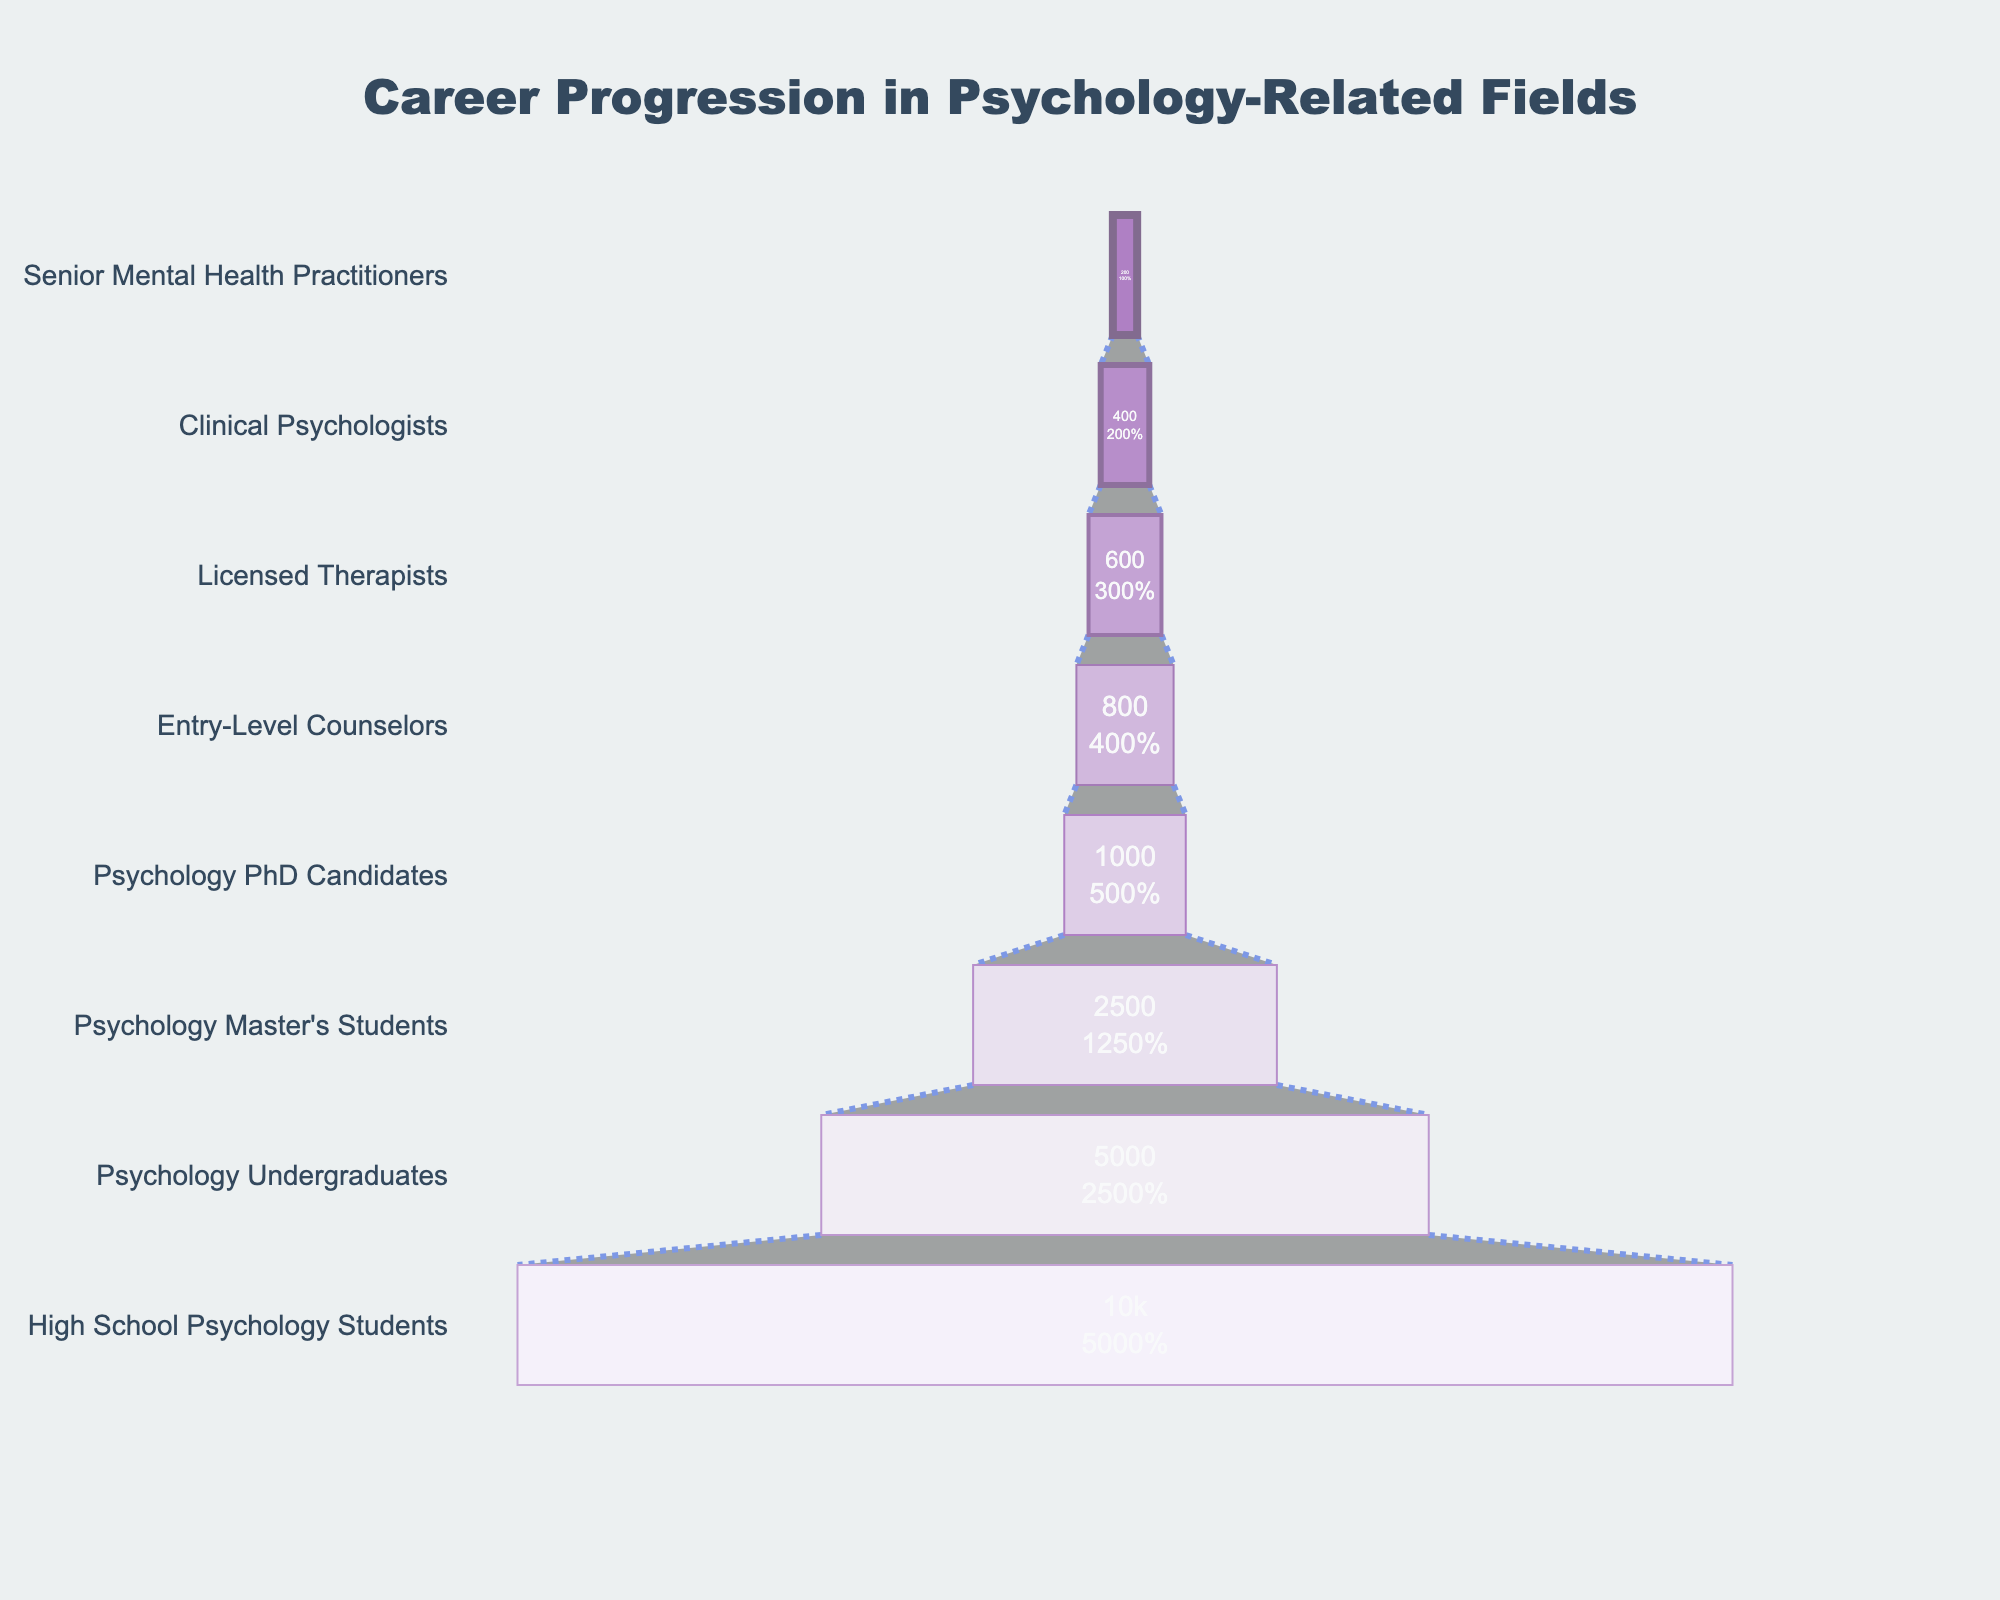What is the title of the figure? The title is usually placed at the top center of the figure and visually distinct in terms of font size and color. Here, it reads "Career Progression in Psychology-Related Fields".
Answer: Career Progression in Psychology-Related Fields Which stage has the highest number of people? The widest part of the funnel represents the stage with the highest number of people, which is at the top. Here, the "High School Psychology Students" stage is the widest with 10,000 people.
Answer: High School Psychology Students What is the number of people at the "Clinical Psychologists" stage? Locate the label "Clinical Psychologists" on the y-axis, then look at the corresponding value inside the funnel section. It shows there are 400 people at this stage.
Answer: 400 How many stages are represented in the funnel chart? Count the number of distinct sections in the funnel. There are eight stages listed from "High School Psychology Students" to "Senior Mental Health Practitioners".
Answer: 8 Which stage has the lowest retention of people? The narrowest part of the funnel indicates the stage with the smallest number of people, which is "Senior Mental Health Practitioners" with 200 people.
Answer: Senior Mental Health Practitioners What percentage of the initial number of people becomes "Licensed Therapists"? To find the percentage, divide the number of "Licensed Therapists" by the number of "High School Psychology Students" and multiply by 100: (600 / 10,000) * 100 = 6%.
Answer: 6% How many more "Entry-Level Counselors" are there compared to "Clinical Psychologists"? Subtract the number of "Clinical Psychologists" from the number of "Entry-Level Counselors": 800 - 400 = 400.
Answer: 400 Which stages have less than 1,000 people remaining? Check the values inside the funnel sections to find stages with numbers less than 1,000. These are "Psychology PhD Candidates" (1,000), "Entry-Level Counselors" (800), "Licensed Therapists" (600), "Clinical Psychologists" (400), and "Senior Mental Health Practitioners" (200).
Answer: Five stages How many people advance from "Psychology Master's Students" to "Psychology PhD Candidates"? Look at the difference between the two stages: 2,500 (Master's Students) - 1,000 (PhD Candidates) = 1,500 people advance.
Answer: 1,500 What is the general trend observed through the stages in terms of the number of people? Observe the funnel's shape which narrows as it progresses downward, indicating a decrease in the number of people advancing to the next stage.
Answer: Decreasing trend 